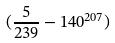Convert formula to latex. <formula><loc_0><loc_0><loc_500><loc_500>( \frac { 5 } { 2 3 9 } - 1 4 0 ^ { 2 0 7 } )</formula> 